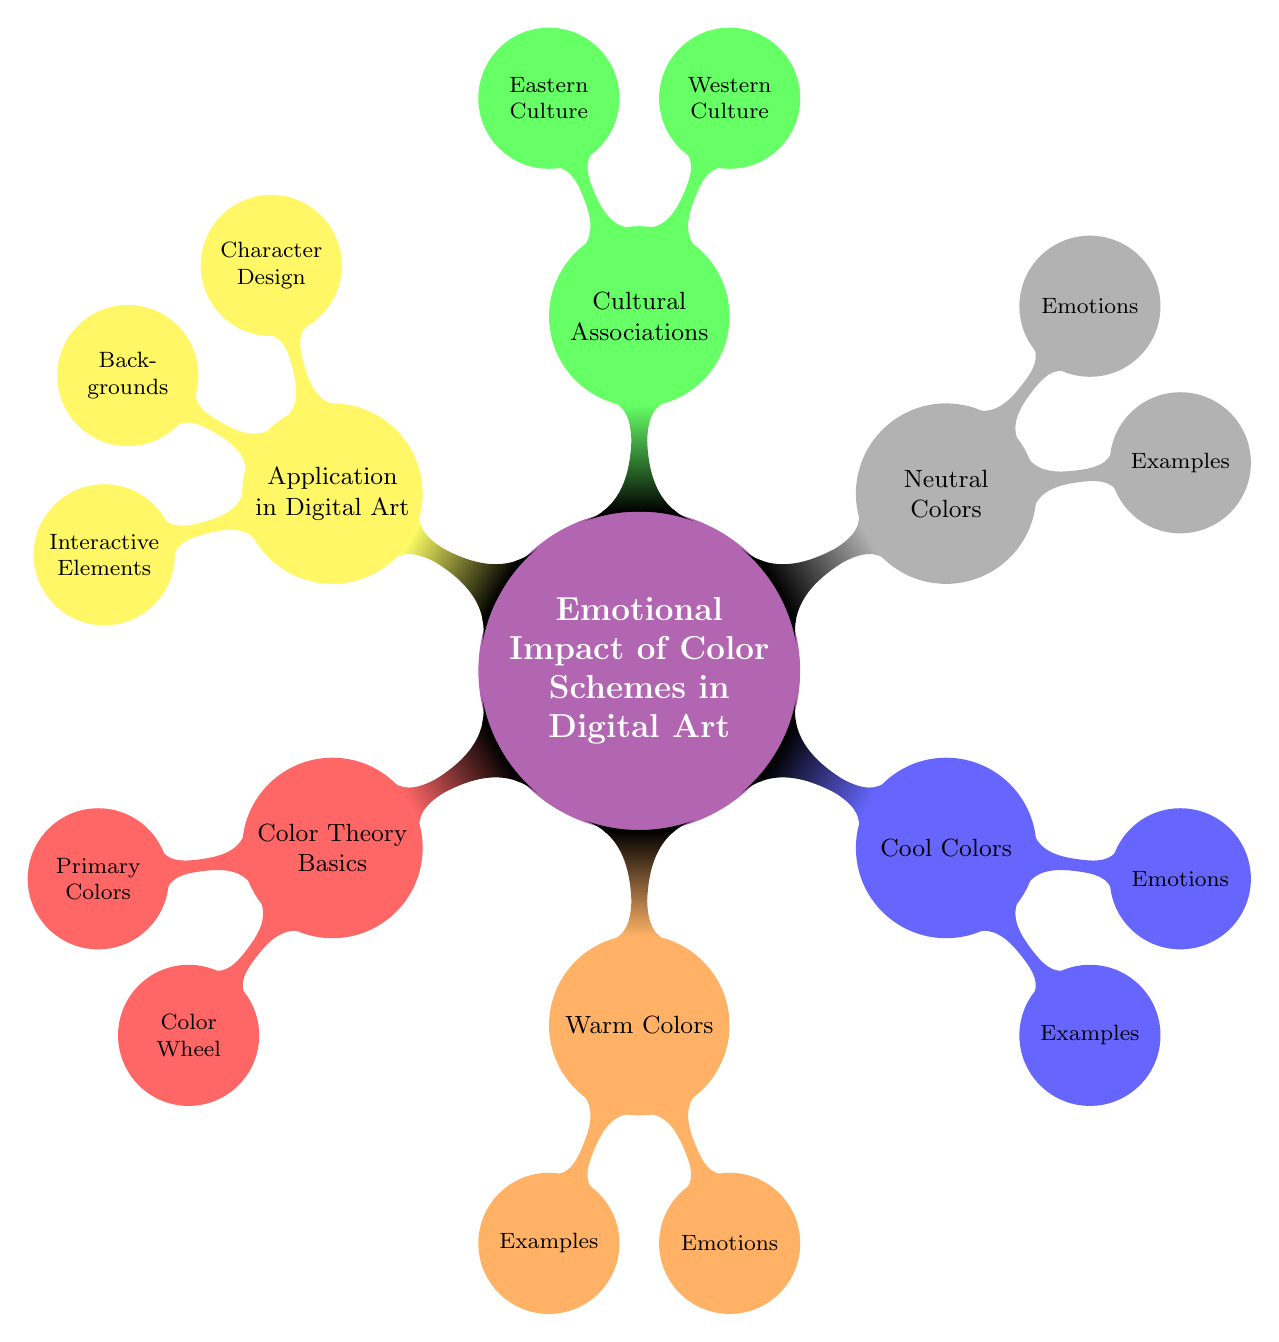What are the primary colors listed in the diagram? The diagram indicates that the primary colors under the "Color Theory Basics" node are Red, Blue, and Yellow.
Answer: Red, Blue, Yellow How many main color categories are there in the Emotional Impact of Color Schemes? There are five main color categories identified in the diagram: Color Theory Basics, Warm Colors, Cool Colors, Neutral Colors, and Cultural Associations.
Answer: Five What emotions are associated with warm colors? The diagram specifies that warm colors evoke excitement, energy, and warmth.
Answer: Excitement, Energy, Warmth What does the Western culture associate with the color red? According to the diagram, Western culture associates the color red with love.
Answer: Love In digital art, what purpose do interactive elements serve? The diagram states that in digital art, interactive elements primarily serve user engagement and visual hierarchy.
Answer: User engagement, Visual hierarchy What is an example of a cool color mentioned in the diagram? The diagram lists blue as an example of a cool color.
Answer: Blue How are primary colors categorized in the color wheel? The diagram mentions that complementary, analogous, and triadic colors are the categorizations in the color wheel.
Answer: Complementary, Analogous, Triadic Which cultural association corresponds to the color white in Eastern culture? The diagram indicates that, in Eastern culture, the color white corresponds with mourning.
Answer: Mourning How do neutral colors impact perception according to the diagram? The diagram states that neutral colors are associated with sophistication, balance, and formality, impacting the perception of artworks.
Answer: Sophistication, Balance, Formality 